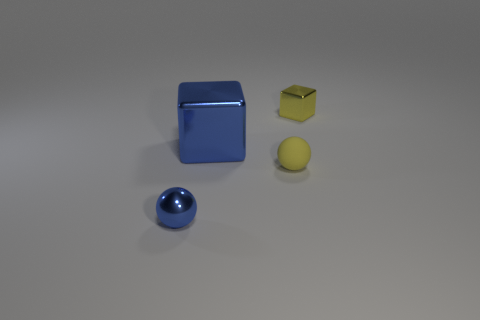Are there any other things that have the same material as the tiny yellow sphere?
Provide a succinct answer. No. Do the object on the left side of the blue metal cube and the large blue metal thing have the same size?
Provide a short and direct response. No. There is a metal object that is to the right of the tiny blue shiny object and in front of the yellow metal thing; what is its size?
Your answer should be compact. Large. Is there a cube on the right side of the yellow matte ball on the left side of the small thing behind the big block?
Your answer should be compact. Yes. What shape is the metal object that is behind the blue shiny ball and on the left side of the small yellow metallic thing?
Make the answer very short. Cube. Is there another object of the same color as the tiny matte object?
Your answer should be compact. Yes. What color is the ball that is to the right of the shiny thing that is on the left side of the big object?
Your answer should be very brief. Yellow. There is a metal object that is on the left side of the metallic block in front of the tiny object that is behind the yellow sphere; how big is it?
Your response must be concise. Small. Do the big blue object and the tiny yellow object in front of the big metal cube have the same material?
Your answer should be very brief. No. There is another block that is made of the same material as the tiny cube; what is its size?
Offer a very short reply. Large. 